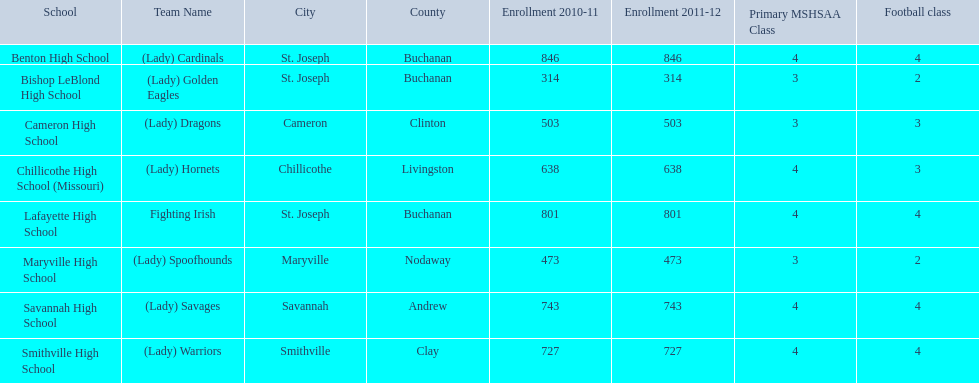How many are enrolled at each school? Benton High School, 846, Bishop LeBlond High School, 314, Cameron High School, 503, Chillicothe High School (Missouri), 638, Lafayette High School, 801, Maryville High School, 473, Savannah High School, 743, Smithville High School, 727. Which school has at only three football classes? Cameron High School, 3, Chillicothe High School (Missouri), 3. Which school has 638 enrolled and 3 football classes? Chillicothe High School (Missouri). 